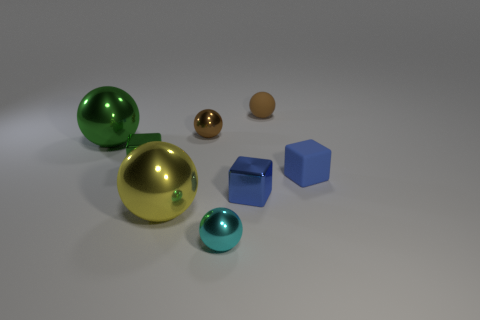There is another small cube that is the same color as the tiny rubber block; what is its material?
Give a very brief answer. Metal. What is the material of the small green thing that is the same shape as the blue rubber thing?
Your answer should be very brief. Metal. What number of big green objects are there?
Keep it short and to the point. 1. What shape is the brown object on the left side of the cyan metal thing?
Your answer should be very brief. Sphere. There is a metal cube that is right of the big thing that is in front of the cube behind the small blue rubber cube; what color is it?
Provide a succinct answer. Blue. What is the shape of the tiny cyan object that is the same material as the green ball?
Make the answer very short. Sphere. Is the number of large objects less than the number of objects?
Your answer should be very brief. Yes. Does the cyan ball have the same material as the green ball?
Ensure brevity in your answer.  Yes. Is the number of tiny yellow shiny cylinders greater than the number of yellow metal things?
Provide a succinct answer. No. There is a blue matte block; is it the same size as the metallic sphere that is left of the small green thing?
Give a very brief answer. No. 